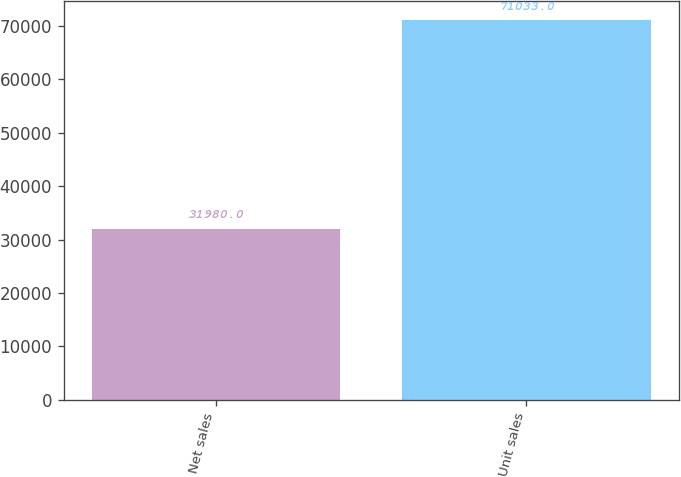Convert chart to OTSL. <chart><loc_0><loc_0><loc_500><loc_500><bar_chart><fcel>Net sales<fcel>Unit sales<nl><fcel>31980<fcel>71033<nl></chart> 